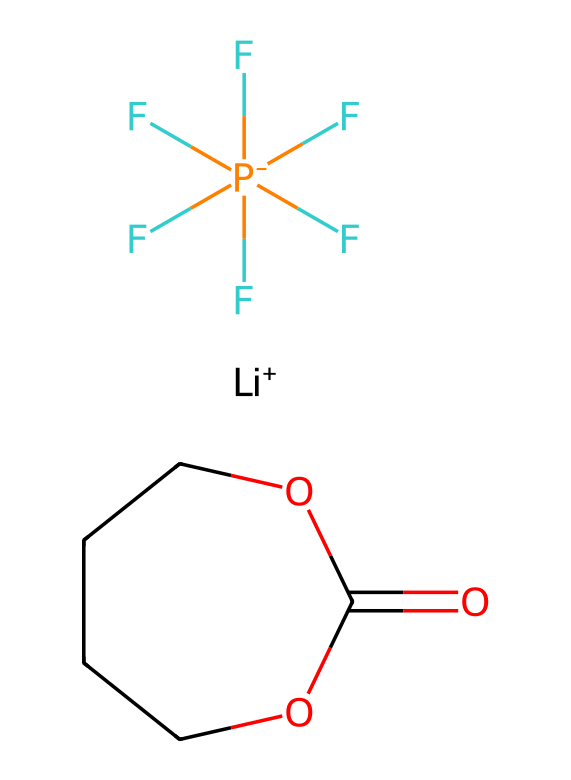What is the total number of carbon atoms in the structure? Counting the carbon atoms present in the SMILES representation, there are two carbon atoms indicated in the cyclic ether (C1COC(=O)OCC1 contains two carbons in a five-membered ring) and another carbon in the ester functional group. Therefore, the total number is three.
Answer: three How many fluorine atoms are present in the molecule? Checking the fluorine atoms in the SMILES notation, there are five listed in the segment "(F)(F)(F)(F)(F)F", indicating that there are five fluorine atoms attached to the phosphorus.
Answer: five What type of bond connects the carbon and oxygen in the ester functional group? In the SMILES representation, the segment "C(=O)O" shows that there is a carbon atom double-bonded to an oxygen (C=O) and single-bonded to another oxygen (C-O). The double bond characterizes it as a carbonyl bond, typical of esters.
Answer: carbonyl What is the charge of lithium in this structure? The notation "[Li+]" clearly indicates that lithium is in a cationic form with a single positive charge.
Answer: positive Which part of the molecule indicates that it is an electrolyte? The inclusion of the anionic component "F[P-](F)(F)(F)(F)F" which implies that this structure has ionic characteristics necessary for conducting electricity, typical of electrolytes.
Answer: ionic component How many rings are present in the molecular structure? From analyzing the partition "C1COC", it indicates a cyclic structure where "1" denotes the start and end of a ring. This depicts one ring in the entire molecule.
Answer: one What type of chemical am I dealing with in lithium-ion battery applications? Considering that this structure comprises a lithium salt and an ester, it represents a lithium salt containing organic solvent suitable for use as an electrolyte in lithium-ion batteries, which are essential for portable energy storage solutions.
Answer: lithium salt and organic solvent 